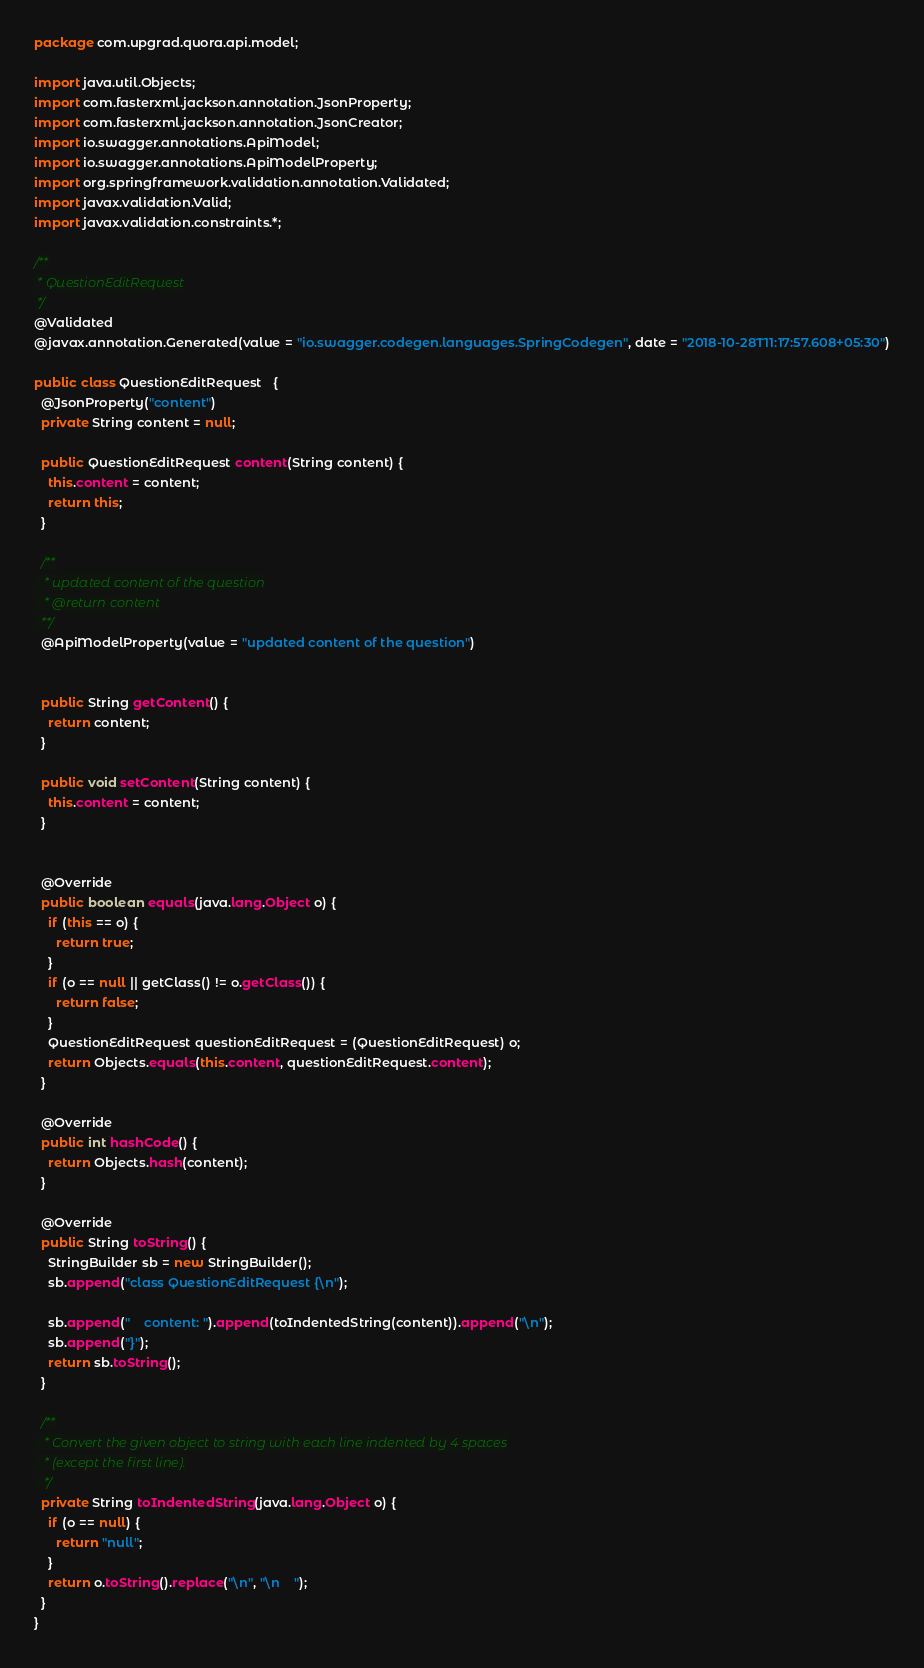Convert code to text. <code><loc_0><loc_0><loc_500><loc_500><_Java_>package com.upgrad.quora.api.model;

import java.util.Objects;
import com.fasterxml.jackson.annotation.JsonProperty;
import com.fasterxml.jackson.annotation.JsonCreator;
import io.swagger.annotations.ApiModel;
import io.swagger.annotations.ApiModelProperty;
import org.springframework.validation.annotation.Validated;
import javax.validation.Valid;
import javax.validation.constraints.*;

/**
 * QuestionEditRequest
 */
@Validated
@javax.annotation.Generated(value = "io.swagger.codegen.languages.SpringCodegen", date = "2018-10-28T11:17:57.608+05:30")

public class QuestionEditRequest   {
  @JsonProperty("content")
  private String content = null;

  public QuestionEditRequest content(String content) {
    this.content = content;
    return this;
  }

  /**
   * updated content of the question
   * @return content
  **/
  @ApiModelProperty(value = "updated content of the question")


  public String getContent() {
    return content;
  }

  public void setContent(String content) {
    this.content = content;
  }


  @Override
  public boolean equals(java.lang.Object o) {
    if (this == o) {
      return true;
    }
    if (o == null || getClass() != o.getClass()) {
      return false;
    }
    QuestionEditRequest questionEditRequest = (QuestionEditRequest) o;
    return Objects.equals(this.content, questionEditRequest.content);
  }

  @Override
  public int hashCode() {
    return Objects.hash(content);
  }

  @Override
  public String toString() {
    StringBuilder sb = new StringBuilder();
    sb.append("class QuestionEditRequest {\n");
    
    sb.append("    content: ").append(toIndentedString(content)).append("\n");
    sb.append("}");
    return sb.toString();
  }

  /**
   * Convert the given object to string with each line indented by 4 spaces
   * (except the first line).
   */
  private String toIndentedString(java.lang.Object o) {
    if (o == null) {
      return "null";
    }
    return o.toString().replace("\n", "\n    ");
  }
}

</code> 